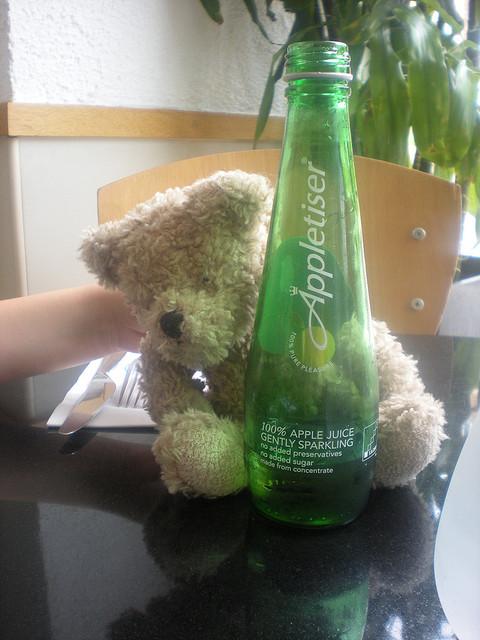What color is the bottle?
Keep it brief. Green. What kind of plant is in the background?
Write a very short answer. Tree. What is the bear drinking?
Give a very brief answer. Apple juice. 